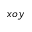<formula> <loc_0><loc_0><loc_500><loc_500>x o y</formula> 